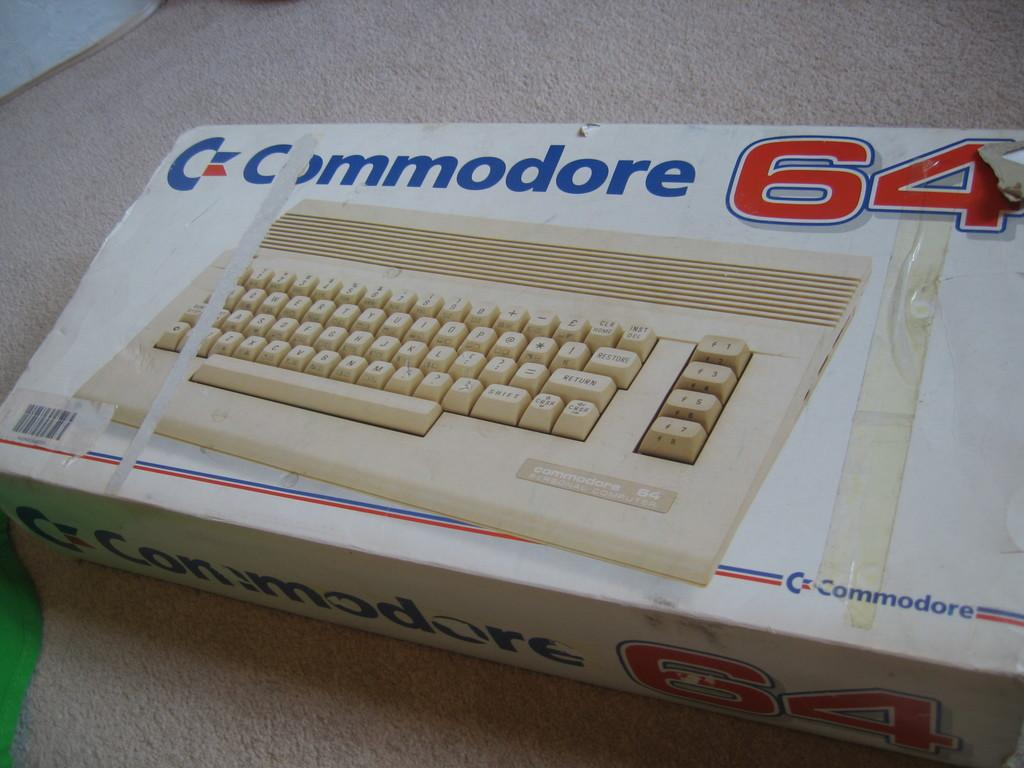<image>
Create a compact narrative representing the image presented. Box of a keyboard named Commodore 64 on top of a table. 